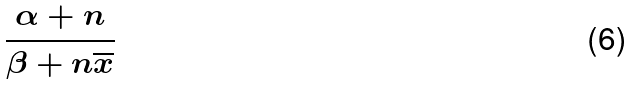<formula> <loc_0><loc_0><loc_500><loc_500>\frac { \alpha + n } { \beta + n \overline { x } }</formula> 